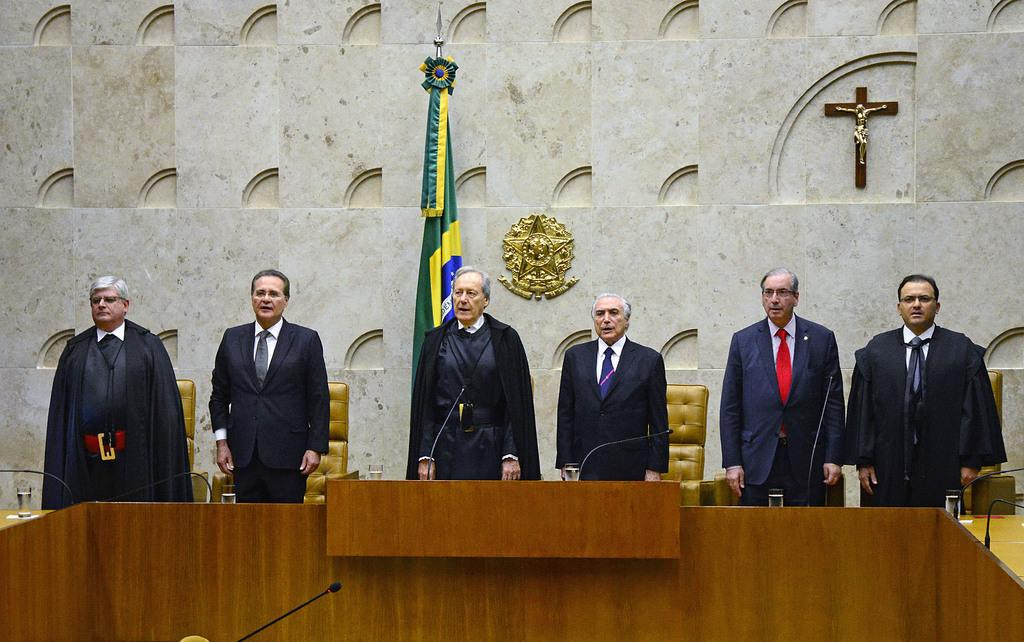How many people are in the group visible in the image? There is a group of people in the image, but the exact number is not specified. What is located in front of the group of people? There is a table in front of the group of people. What items can be seen on the table? There are microphones (mics) and glasses on the table. What can be seen in the background of the image? There are chairs, a wall, a flag, a shield, and a cross in the background of the image. What type of park is visible in the background of the image? There is no park visible in the background of the image. How much money is on the table in the image? There is no mention of money on the table in the image. 